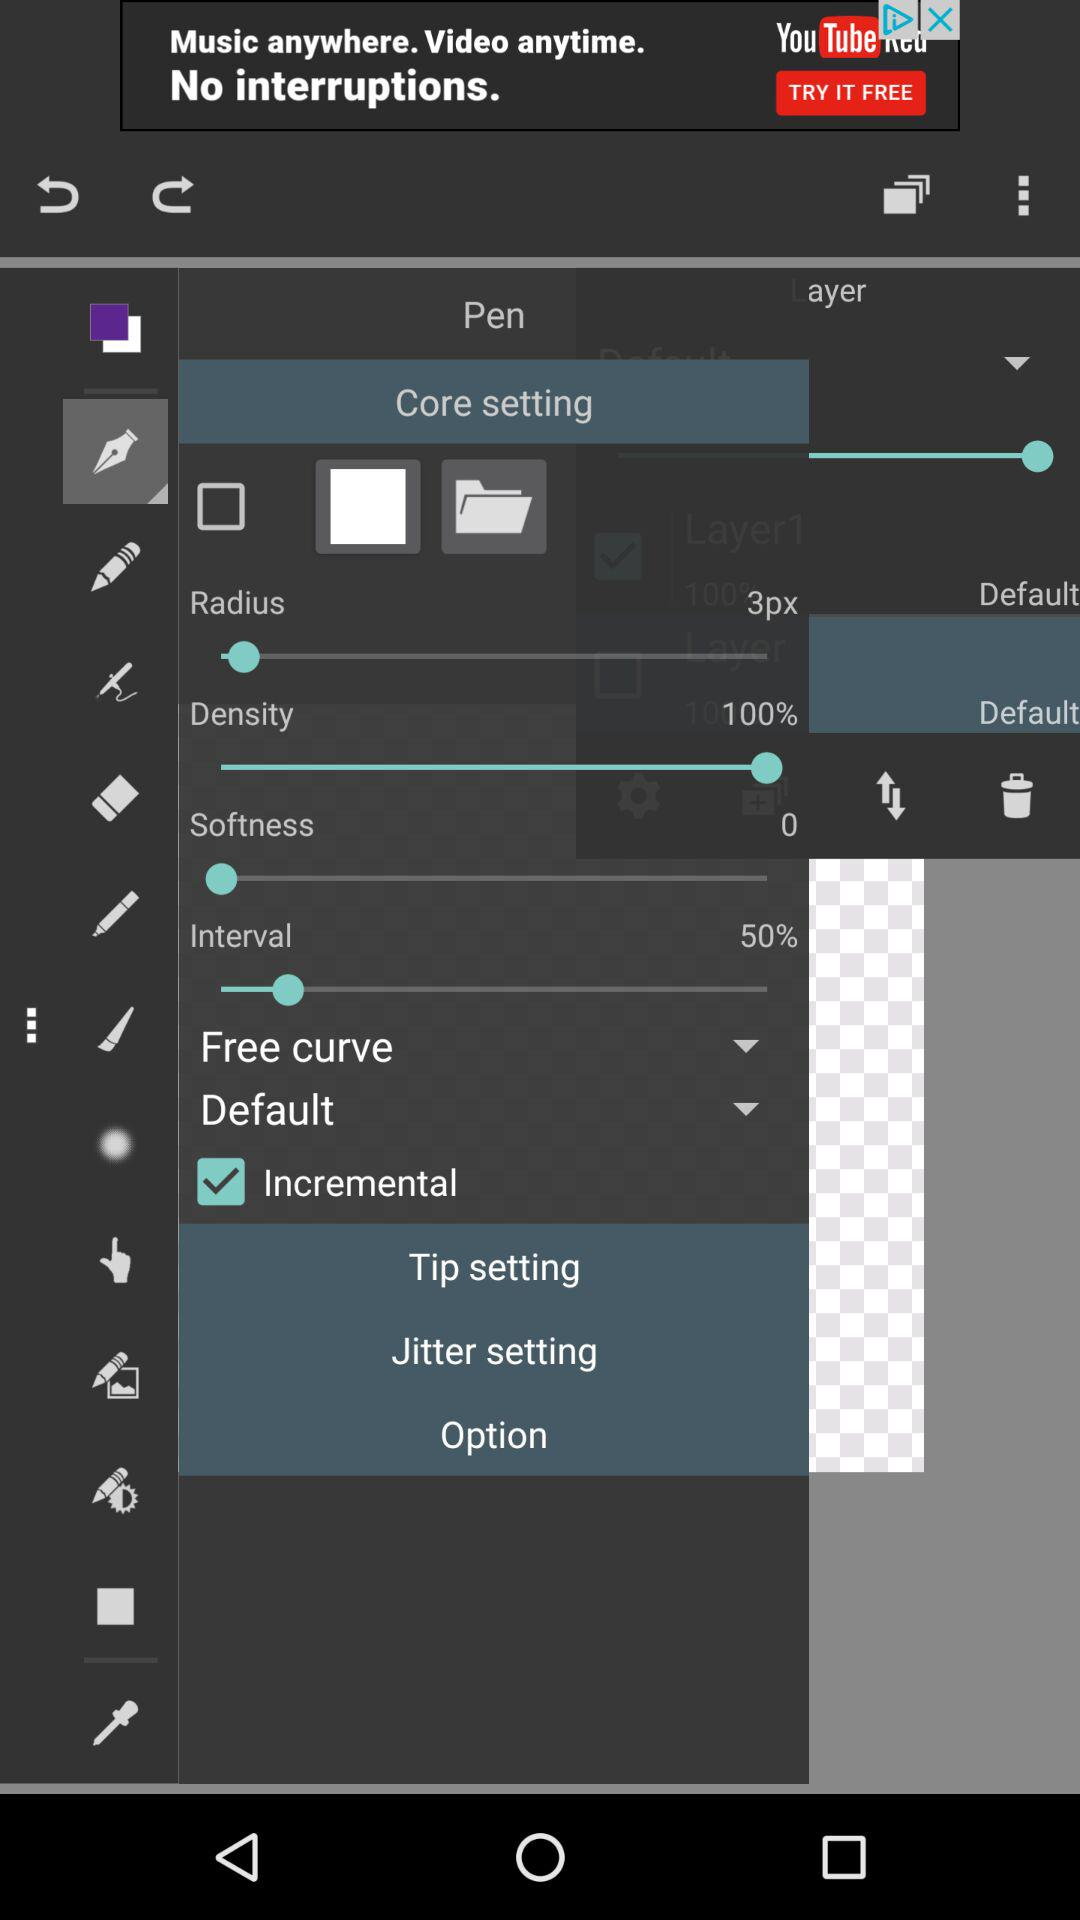What is the status of density? The status of density is 100%. 